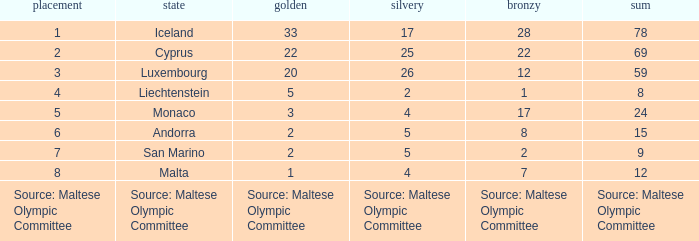What is the total medal count for the nation that has 5 gold? 8.0. 